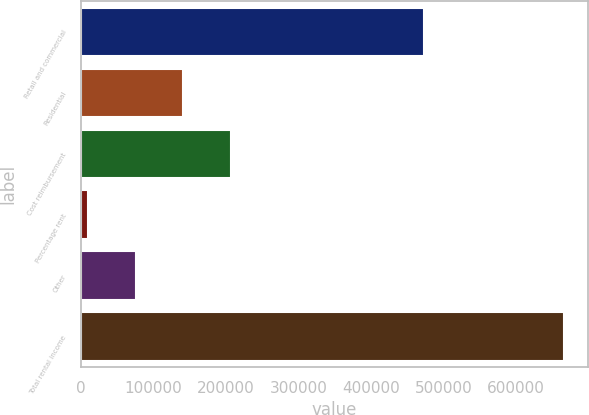<chart> <loc_0><loc_0><loc_500><loc_500><bar_chart><fcel>Retail and commercial<fcel>Residential<fcel>Cost reimbursement<fcel>Percentage rent<fcel>Other<fcel>Total rental income<nl><fcel>472602<fcel>141400<fcel>207015<fcel>10169<fcel>75784.3<fcel>666322<nl></chart> 